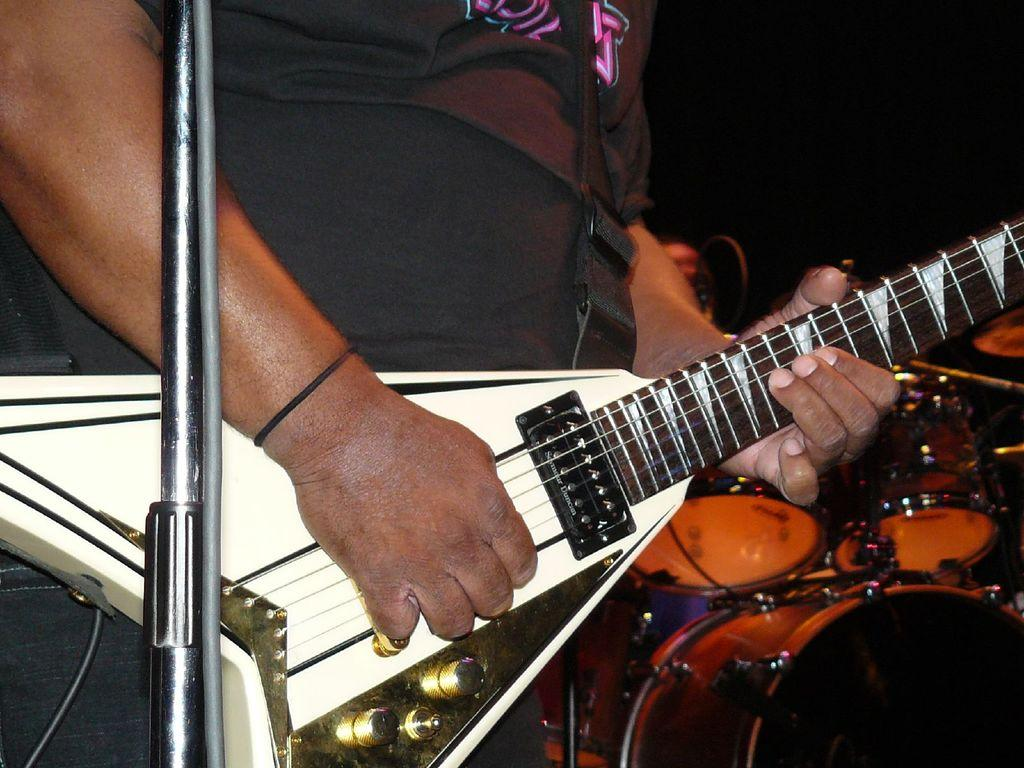What is the person in the image doing? The person in the image is playing a guitar. What other musical instruments can be seen in the image? There are musical drums in the bottom right of the image. What object is located on the left side of the image? There is a metal rod and wire on the left side of the image. What type of animal is offering a treat to the person playing the guitar in the image? There is no animal present in the image, and therefore no such offering can be observed. 